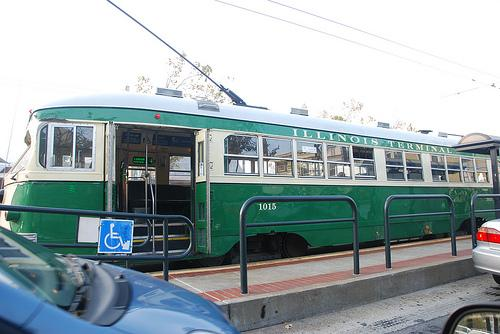State the color of the car mentioned in the image and specify its position. The car front is blue and is located at the left side of the image. Describe the main activity depicted by the two white people in the image. Two white people are standing in front of a giraffe, possibly observing or interacting with it. Briefly mention the type and color of the signage found in the image. There is a blue and white sign, as well as a blue handicapped sign in the image. Describe the state of the doors on the primary transportation vehicle in the image. The doors on the green bus are open. Mention one unique feature of the train and describe it. A train has a window, which is rectangular in shape and made of glass. Enumerate the features related to the green bus in this image. The green bus has open doors, steps, a shelter at the bus stop, white numbers and letters painted on it, and multiple windows. What type of sign is present near a railing in the image? Describe its color. A blue handicap sign is located on the rail in the image. Identify the dominant transportation vehicle in the image and specify its color. A long green bus parked next to a curb is the main transportation vehicle in the picture. What are the primary features of the sidewalk in the image? The sidewalk is paved, and there are rails on it. What type of path can be seen in the image, and what is its composition? A concrete walkway is visible in the image, made of solid ground material. 